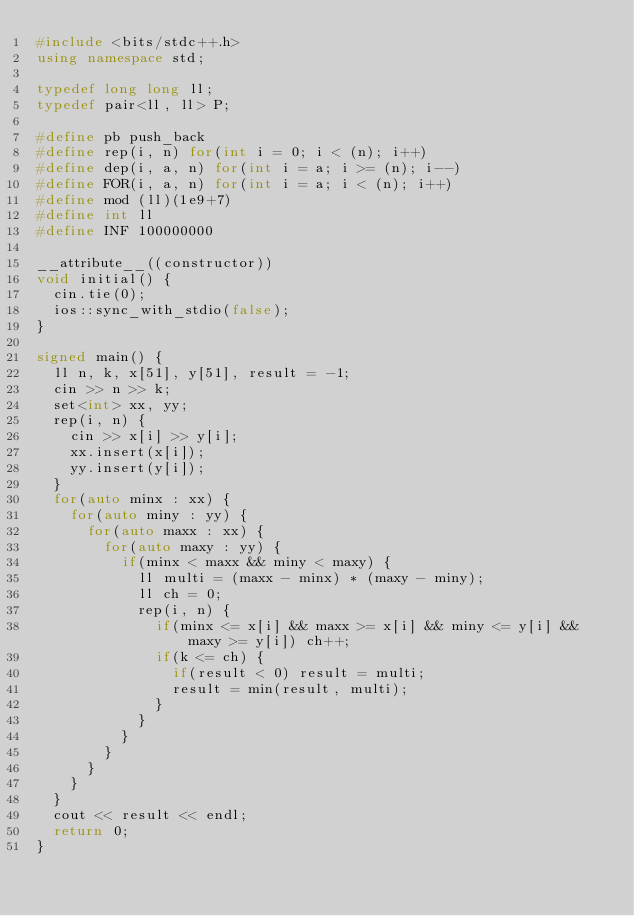Convert code to text. <code><loc_0><loc_0><loc_500><loc_500><_C++_>#include <bits/stdc++.h>
using namespace std;

typedef long long ll;
typedef pair<ll, ll> P;

#define pb push_back
#define rep(i, n) for(int i = 0; i < (n); i++)
#define dep(i, a, n) for(int i = a; i >= (n); i--)
#define FOR(i, a, n) for(int i = a; i < (n); i++)
#define mod (ll)(1e9+7)
#define int ll
#define INF 100000000

__attribute__((constructor))
void initial() {
  cin.tie(0);
  ios::sync_with_stdio(false);
}

signed main() {
	ll n, k, x[51], y[51], result = -1;
  cin >> n >> k;
  set<int> xx, yy;
  rep(i, n) {
    cin >> x[i] >> y[i];
    xx.insert(x[i]);
    yy.insert(y[i]);
  }
  for(auto minx : xx) {
    for(auto miny : yy) {
      for(auto maxx : xx) {
        for(auto maxy : yy) {
          if(minx < maxx && miny < maxy) {
            ll multi = (maxx - minx) * (maxy - miny);
            ll ch = 0;
            rep(i, n) {
              if(minx <= x[i] && maxx >= x[i] && miny <= y[i] && maxy >= y[i]) ch++;
              if(k <= ch) {
                if(result < 0) result = multi;
                result = min(result, multi);
              }
            }
          }
        }
      }
    }
  }
  cout << result << endl;
	return 0;
}</code> 